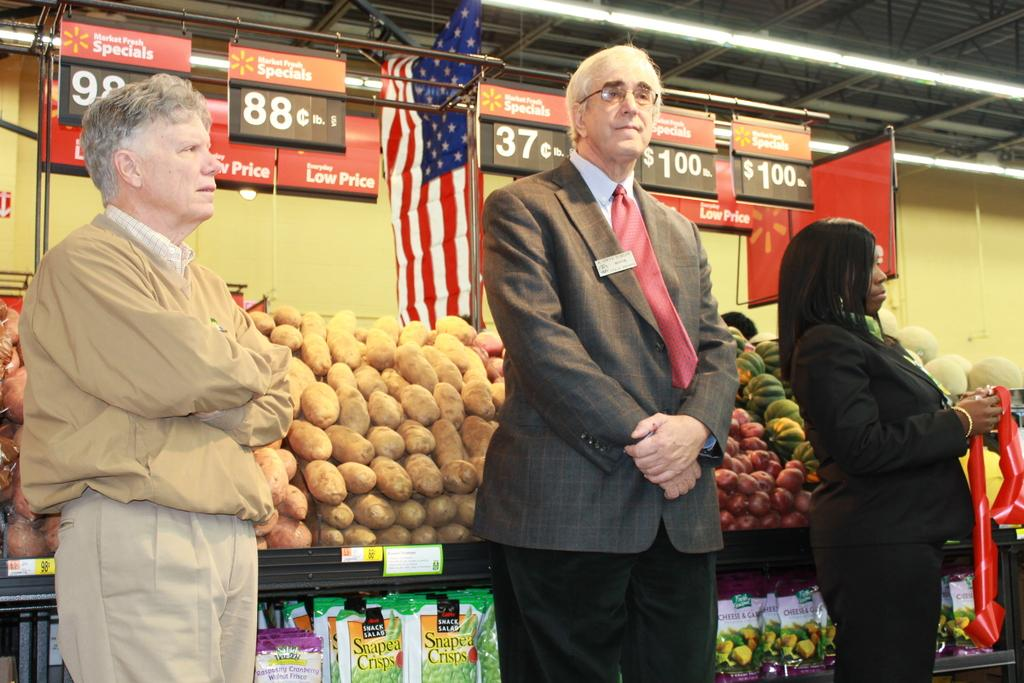<image>
Offer a succinct explanation of the picture presented. a man standing in front of a price sign that says 37 cents on it 